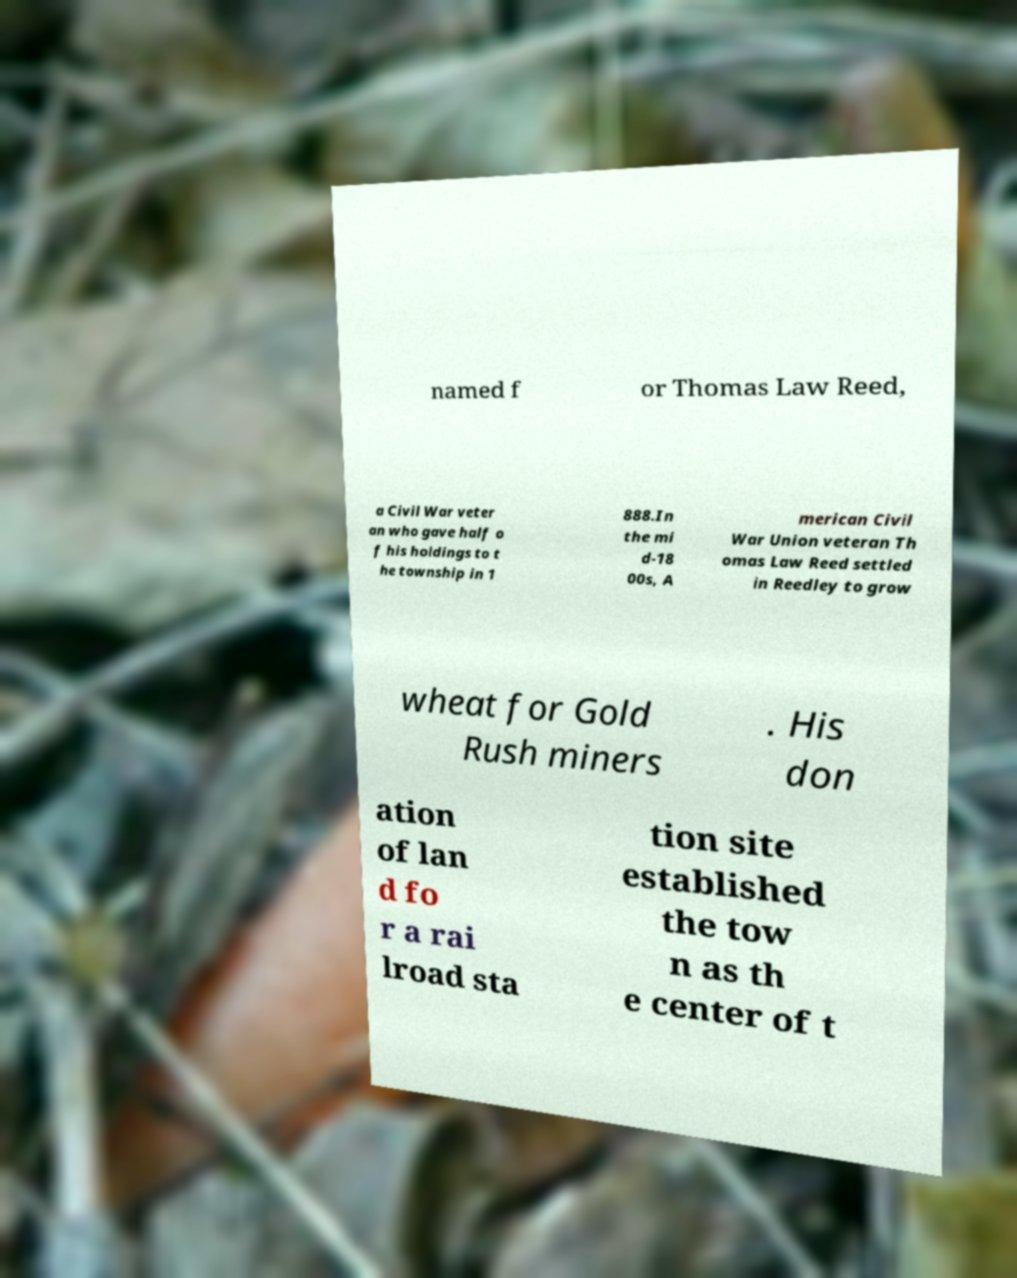Can you read and provide the text displayed in the image?This photo seems to have some interesting text. Can you extract and type it out for me? named f or Thomas Law Reed, a Civil War veter an who gave half o f his holdings to t he township in 1 888.In the mi d-18 00s, A merican Civil War Union veteran Th omas Law Reed settled in Reedley to grow wheat for Gold Rush miners . His don ation of lan d fo r a rai lroad sta tion site established the tow n as th e center of t 